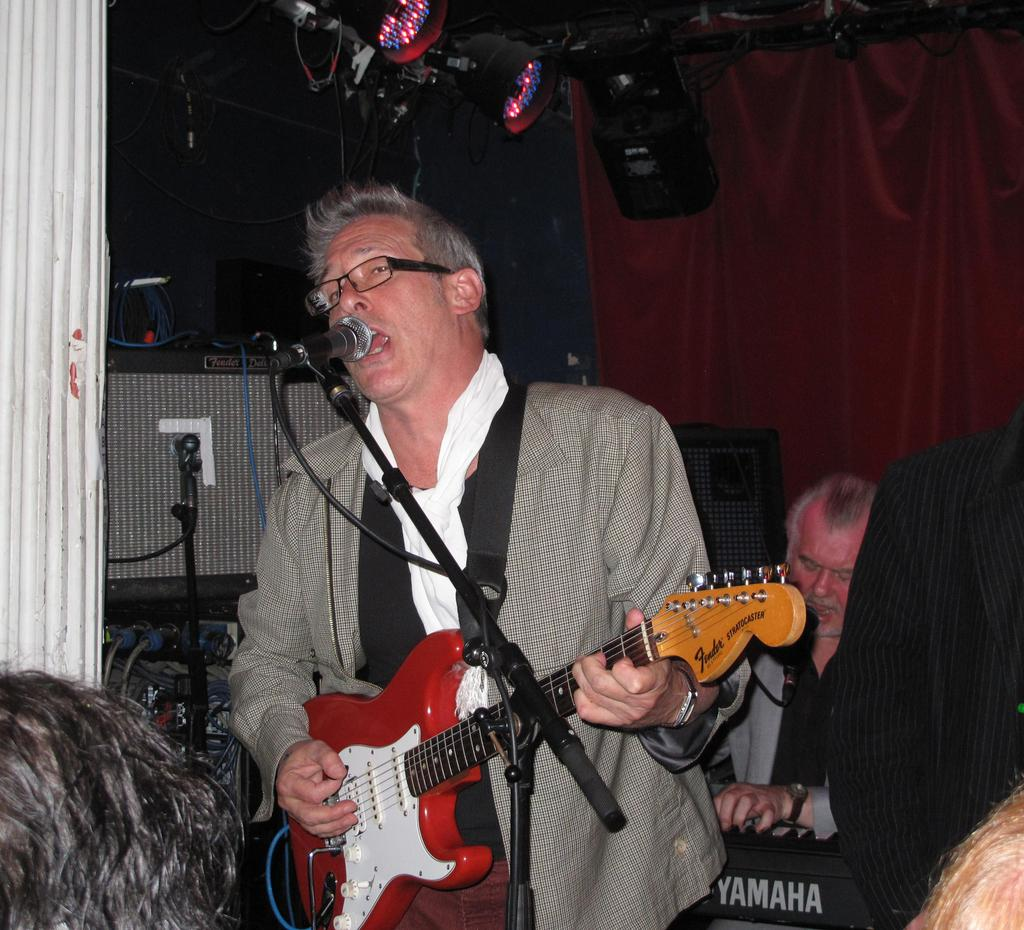What is the man in the image doing? The man is standing, playing a guitar, and singing. What object is the man using to amplify his voice? The man is in front of a microphone. What can be seen in the background of the image? There are lights and a curtain visible in the background. Are there any other people present in the image? Yes, there is a man sitting in the background. What type of spark can be seen coming from the guitar in the image? There is no spark visible coming from the guitar in the image. What kind of bat is flying in the background of the image? There is no bat present in the image; it features a man playing a guitar, singing, and standing in front of a microphone. 